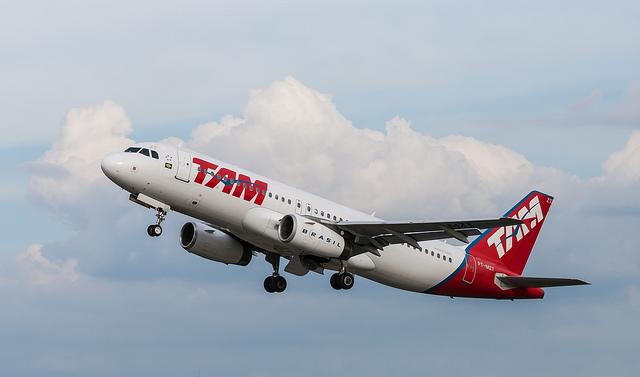What kind of vehicle is this?
Short answer required. Airplane. What company is this plane part of?
Write a very short answer. Tam. How many engines does this plane have?
Keep it brief. 2. What country is written on the wing?
Be succinct. Brazil. Is the plane ascending or descending?
Write a very short answer. Ascending. 